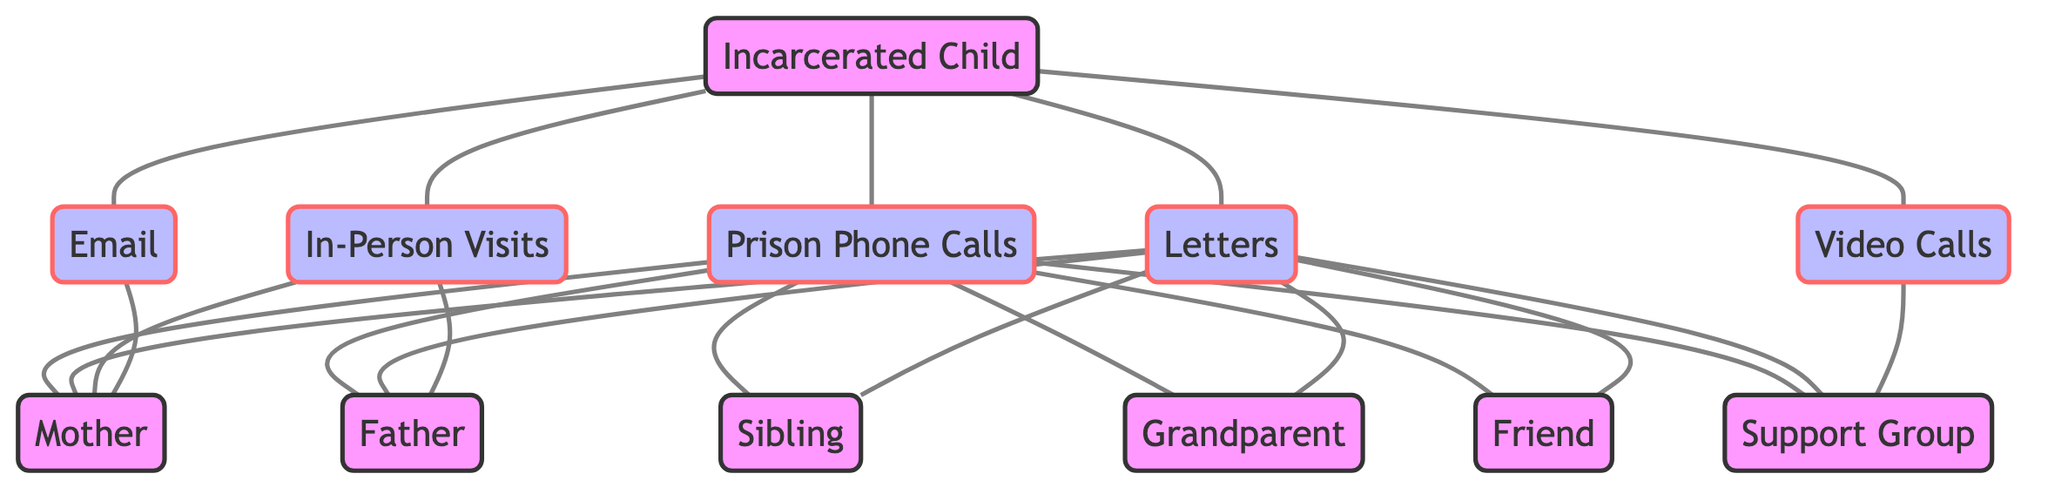What relationships does the Incarcerated Child have with the Mother? The Incarcerated Child has four relationships with the Mother: Letters, Prison Phone Calls, In-Person Visits, and Email. Each of these relationships is represented as an edge connecting the Incarcerated Child node to the Mother node with the corresponding labels.
Answer: Letters, Prison Phone Calls, In-Person Visits, Email How many communication channels are available from the Incarcerated Child to friends? There are two communication channels available from the Incarcerated Child to friends, which are Letters and Prison Phone Calls. Each channel is depicted as an edge between the Incarcerated Child and the Friend nodes.
Answer: 2 Which family member has access to the highest number of communication methods with the Incarcerated Child? The Mother has access to the highest number of communication methods with the Incarcerated Child, which are four: Letters, Prison Phone Calls, In-Person Visits, and Email. Counting these edges shows that she is linked to the Incarcerated Child through the most channels.
Answer: Mother What is the total number of nodes in the diagram? The diagram contains a total of 12 nodes: Incarcerated Child, Mother, Father, Sibling, Grandparent, Friend, Support Group, Prison Phone Calls, Letters, In-Person Visits, Email, and Video Calls. By counting each unique identifier in the nodes list, we get the total.
Answer: 12 What type of communication is only used with the Support Group? The type of communication used only with the Support Group is Video Calls. This can be determined by locating the Support Group node and checking the edges connected to it, revealing that Video Calls is the sole method linked exclusively to them.
Answer: Video Calls How many edges are present in the diagram that involve Prison Phone Calls? There are six edges present in the diagram that involve Prison Phone Calls. Each edge represents a connection from the Incarcerated Child to each of the family members and the Support Group, indicating six different communication arrangements using this channel.
Answer: 6 Which nodes represent family members in the diagram? The nodes representing family members are Mother, Father, Sibling, and Grandparent. By identifying nodes that depict family relationships and checking their labels, these four can be concluded.
Answer: Mother, Father, Sibling, Grandparent Is there an edge connecting the Incarcerated Child and Grandparent through Email? No, there is no edge connecting the Incarcerated Child and Grandparent through Email. The Email node is only connected to the Mother, and checking the diagram for edges confirms this absence of connection.
Answer: No 